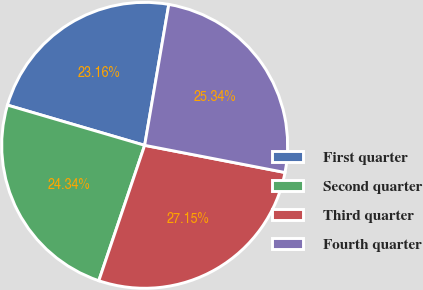Convert chart. <chart><loc_0><loc_0><loc_500><loc_500><pie_chart><fcel>First quarter<fcel>Second quarter<fcel>Third quarter<fcel>Fourth quarter<nl><fcel>23.16%<fcel>24.34%<fcel>27.15%<fcel>25.34%<nl></chart> 